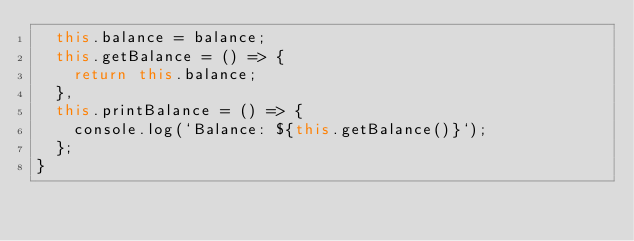<code> <loc_0><loc_0><loc_500><loc_500><_JavaScript_>  this.balance = balance;
  this.getBalance = () => {
    return this.balance;
  },
  this.printBalance = () => {
    console.log(`Balance: ${this.getBalance()}`);
  };
}
</code> 